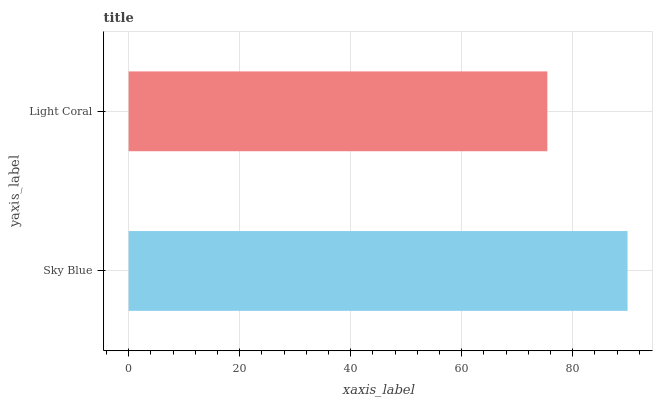Is Light Coral the minimum?
Answer yes or no. Yes. Is Sky Blue the maximum?
Answer yes or no. Yes. Is Light Coral the maximum?
Answer yes or no. No. Is Sky Blue greater than Light Coral?
Answer yes or no. Yes. Is Light Coral less than Sky Blue?
Answer yes or no. Yes. Is Light Coral greater than Sky Blue?
Answer yes or no. No. Is Sky Blue less than Light Coral?
Answer yes or no. No. Is Sky Blue the high median?
Answer yes or no. Yes. Is Light Coral the low median?
Answer yes or no. Yes. Is Light Coral the high median?
Answer yes or no. No. Is Sky Blue the low median?
Answer yes or no. No. 